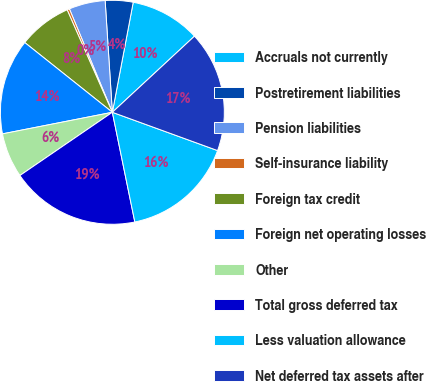<chart> <loc_0><loc_0><loc_500><loc_500><pie_chart><fcel>Accruals not currently<fcel>Postretirement liabilities<fcel>Pension liabilities<fcel>Self-insurance liability<fcel>Foreign tax credit<fcel>Foreign net operating losses<fcel>Other<fcel>Total gross deferred tax<fcel>Less valuation allowance<fcel>Net deferred tax assets after<nl><fcel>10.12%<fcel>4.01%<fcel>5.24%<fcel>0.35%<fcel>7.68%<fcel>13.79%<fcel>6.46%<fcel>18.67%<fcel>16.23%<fcel>17.45%<nl></chart> 